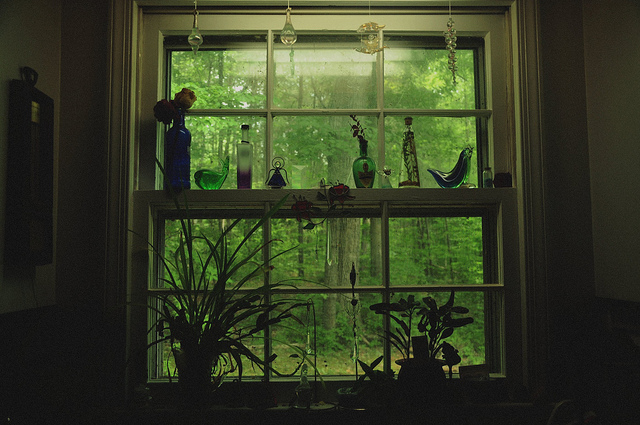Describe the outdoor scenery visible through the window. Through the window, the outdoor scenery is filled with an expanse of green foliage indicating a dense forest or a heavily wooded area. The leaves are vibrant and healthy, hinting at a lush, natural environment, untouched by human activity. The trees outside provide a calming green backdrop that complements the serene indoor space filled with plants and glass decor. Do you think this setting might be a part of someone's everyday life, like in a countryside home? The setting does indeed give an impression of a tranquil, countryside home. The presence of various potted plants and the array of carefully selected glass vases on the windowsill suggest a space that is both cared for and aesthetically pleasing. The view of the lush, green outdoors enhances this feeling of calm and connection to nature, typically found in countryside dwellings. This environment seems to be a peaceful retreat, offering a seamless blend of indoor comfort and outdoor beauty. 